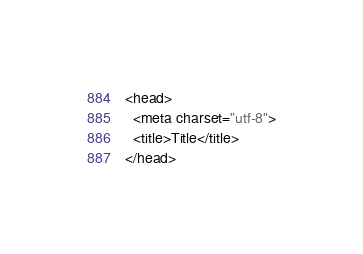<code> <loc_0><loc_0><loc_500><loc_500><_HTML_><head>
  <meta charset="utf-8">
  <title>Title</title>
</head>
</code> 